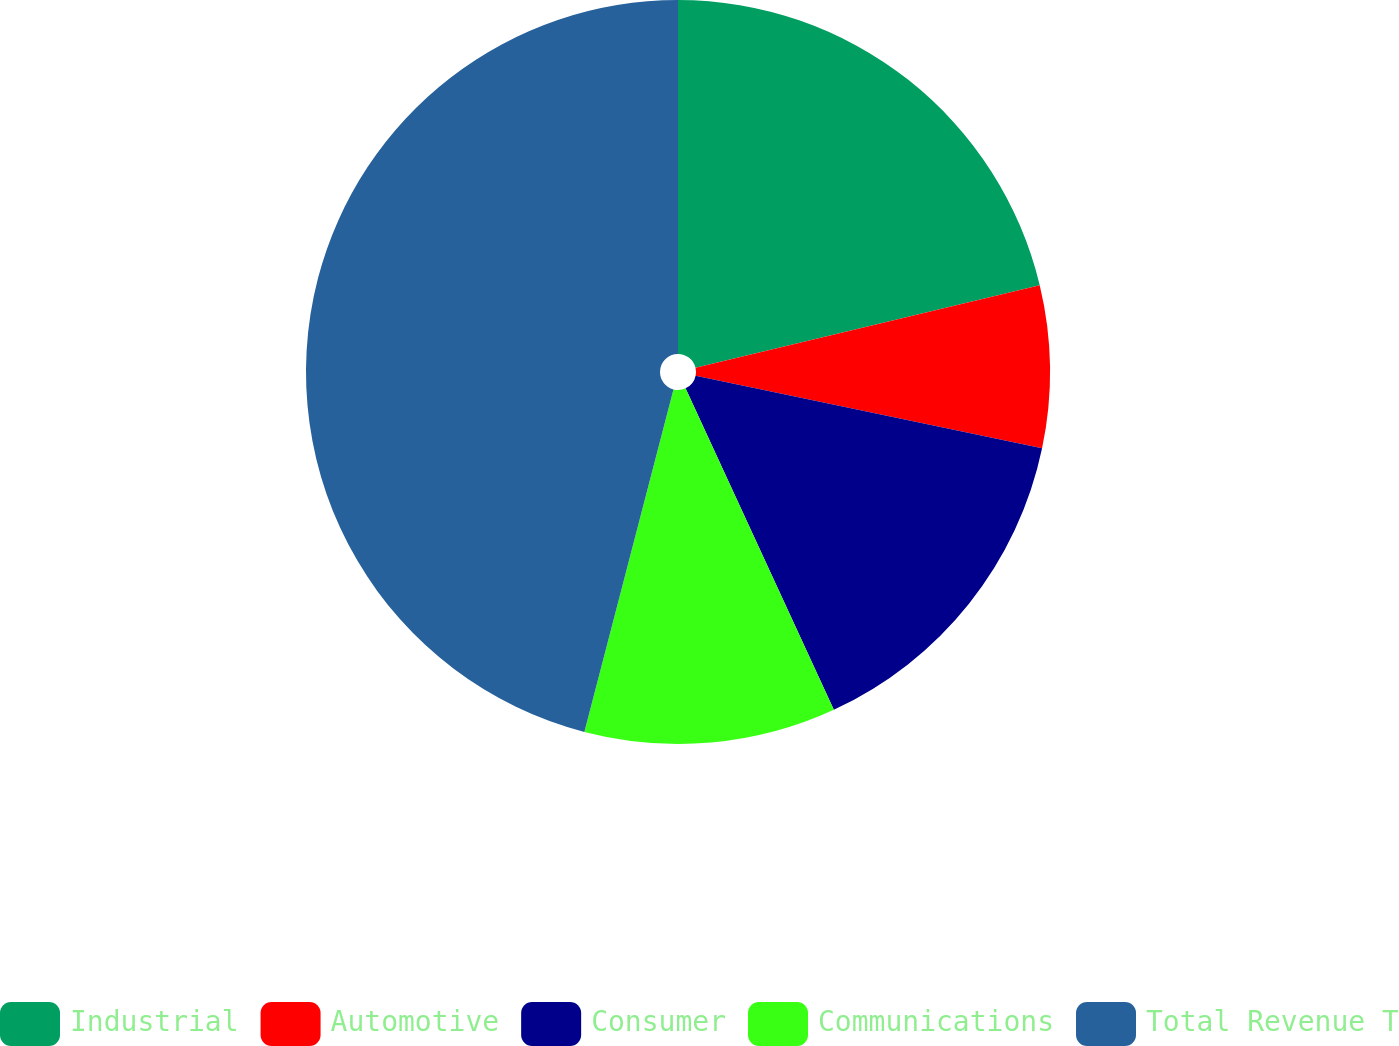<chart> <loc_0><loc_0><loc_500><loc_500><pie_chart><fcel>Industrial<fcel>Automotive<fcel>Consumer<fcel>Communications<fcel>Total Revenue T<nl><fcel>21.25%<fcel>7.04%<fcel>14.83%<fcel>10.93%<fcel>45.95%<nl></chart> 